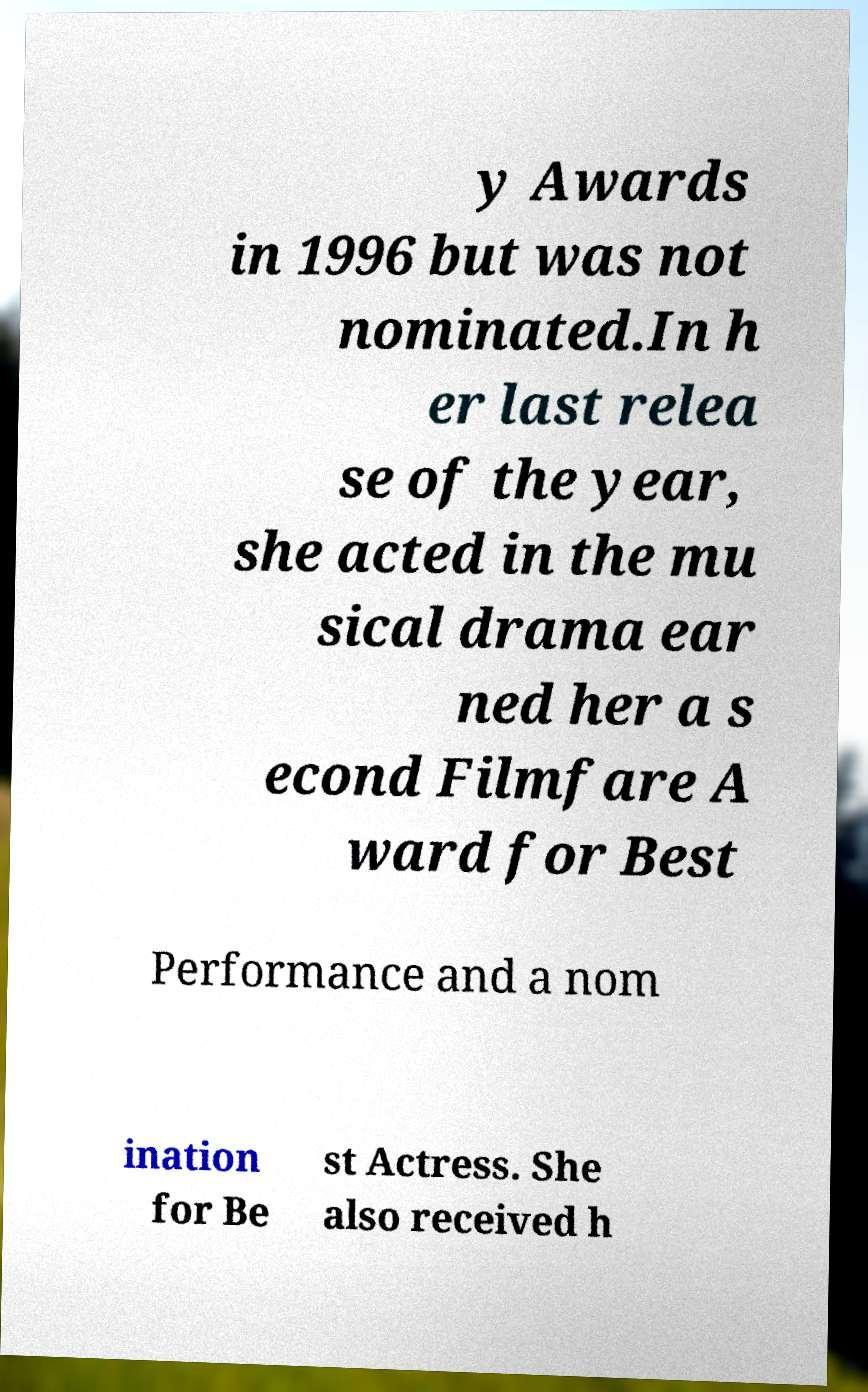Could you extract and type out the text from this image? y Awards in 1996 but was not nominated.In h er last relea se of the year, she acted in the mu sical drama ear ned her a s econd Filmfare A ward for Best Performance and a nom ination for Be st Actress. She also received h 